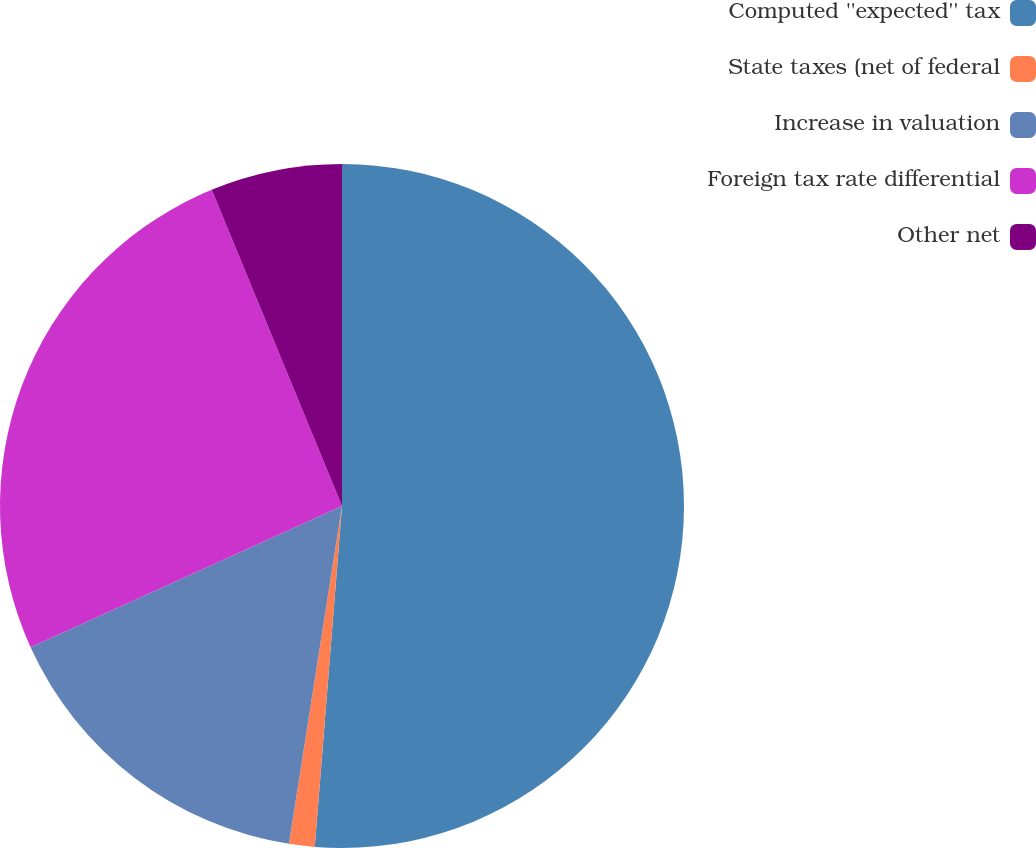Convert chart to OTSL. <chart><loc_0><loc_0><loc_500><loc_500><pie_chart><fcel>Computed ''expected'' tax<fcel>State taxes (net of federal<fcel>Increase in valuation<fcel>Foreign tax rate differential<fcel>Other net<nl><fcel>51.27%<fcel>1.21%<fcel>15.74%<fcel>25.56%<fcel>6.22%<nl></chart> 